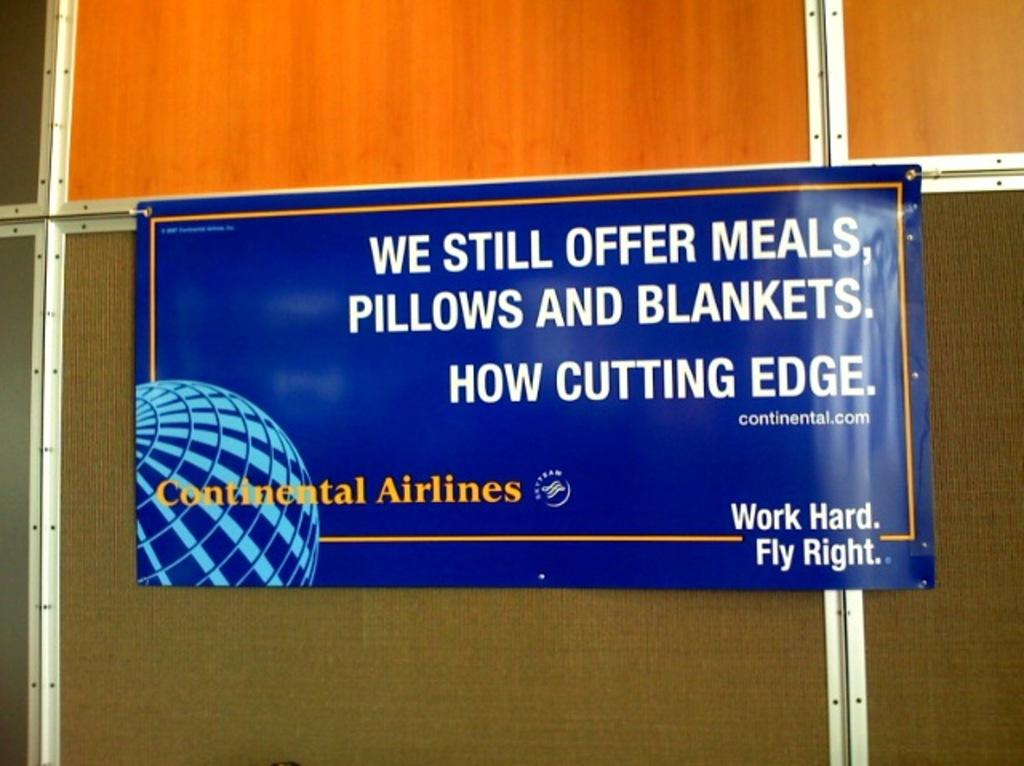<image>
Write a terse but informative summary of the picture. A Continental Airlines sign has its website on it. 